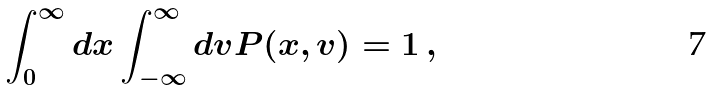<formula> <loc_0><loc_0><loc_500><loc_500>\int _ { 0 } ^ { \infty } d x \int _ { - \infty } ^ { \infty } d v P ( x , v ) = 1 \, ,</formula> 